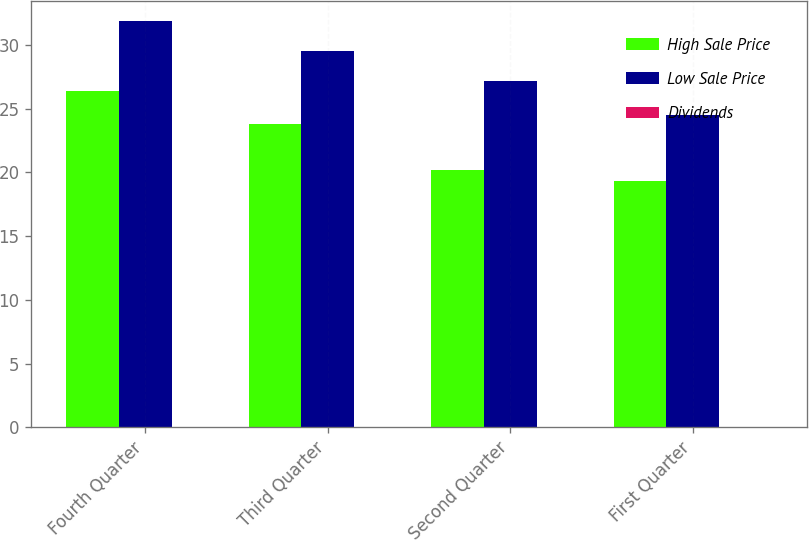Convert chart to OTSL. <chart><loc_0><loc_0><loc_500><loc_500><stacked_bar_chart><ecel><fcel>Fourth Quarter<fcel>Third Quarter<fcel>Second Quarter<fcel>First Quarter<nl><fcel>High Sale Price<fcel>26.41<fcel>23.83<fcel>20.16<fcel>19.32<nl><fcel>Low Sale Price<fcel>31.85<fcel>29.5<fcel>27.17<fcel>24.47<nl><fcel>Dividends<fcel>0.05<fcel>0.05<fcel>0.05<fcel>0.05<nl></chart> 